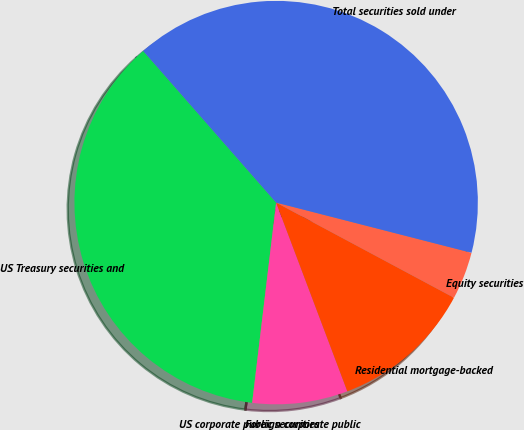<chart> <loc_0><loc_0><loc_500><loc_500><pie_chart><fcel>US Treasury securities and<fcel>US corporate public securities<fcel>Foreign corporate public<fcel>Residential mortgage-backed<fcel>Equity securities<fcel>Total securities sold under<nl><fcel>36.65%<fcel>0.01%<fcel>7.63%<fcel>11.44%<fcel>3.82%<fcel>40.46%<nl></chart> 